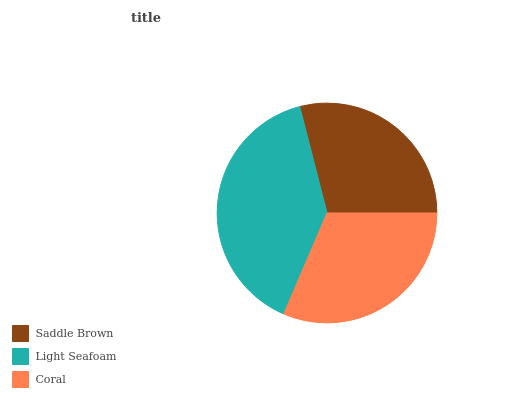Is Saddle Brown the minimum?
Answer yes or no. Yes. Is Light Seafoam the maximum?
Answer yes or no. Yes. Is Coral the minimum?
Answer yes or no. No. Is Coral the maximum?
Answer yes or no. No. Is Light Seafoam greater than Coral?
Answer yes or no. Yes. Is Coral less than Light Seafoam?
Answer yes or no. Yes. Is Coral greater than Light Seafoam?
Answer yes or no. No. Is Light Seafoam less than Coral?
Answer yes or no. No. Is Coral the high median?
Answer yes or no. Yes. Is Coral the low median?
Answer yes or no. Yes. Is Light Seafoam the high median?
Answer yes or no. No. Is Saddle Brown the low median?
Answer yes or no. No. 